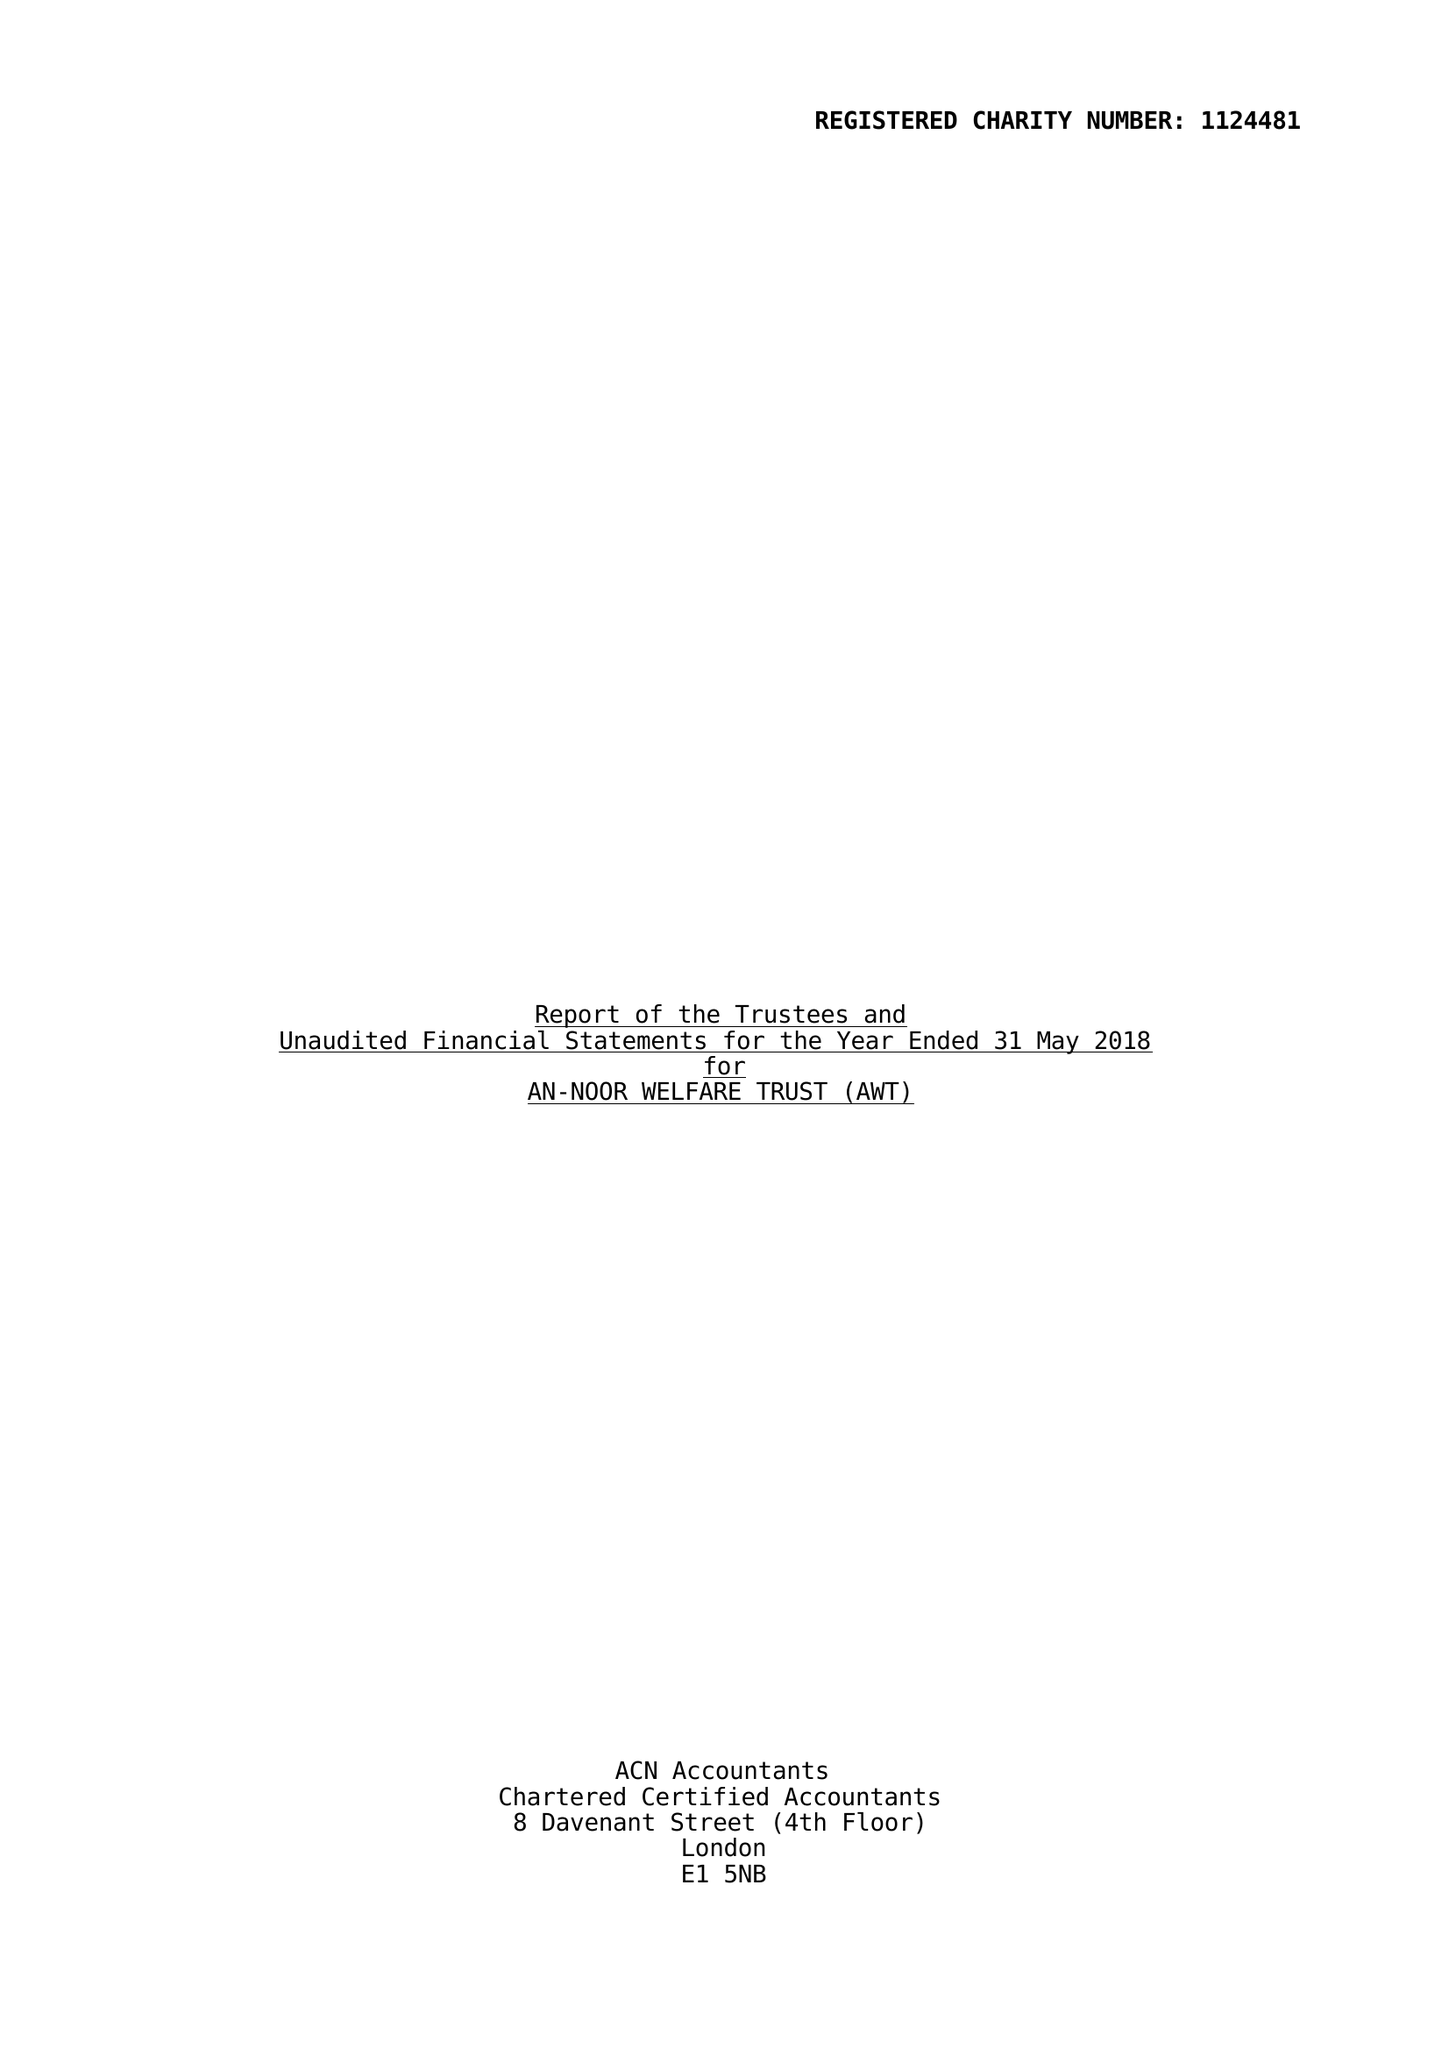What is the value for the charity_name?
Answer the question using a single word or phrase. An-Noor Welfare Trust (Awt) 